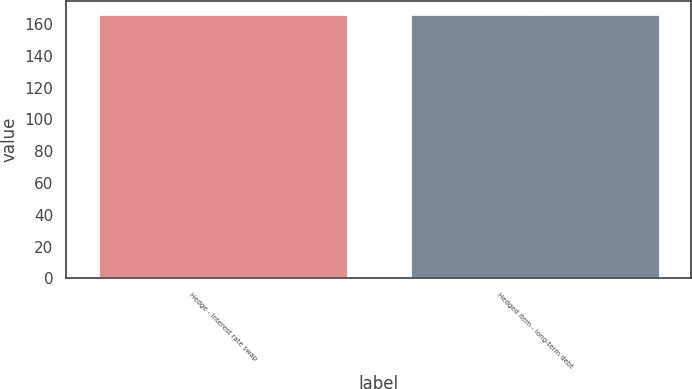Convert chart. <chart><loc_0><loc_0><loc_500><loc_500><bar_chart><fcel>Hedge - interest rate swap<fcel>Hedged item - long-term debt<nl><fcel>166<fcel>166.1<nl></chart> 